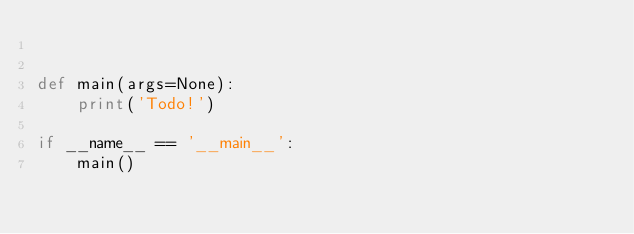Convert code to text. <code><loc_0><loc_0><loc_500><loc_500><_Python_>

def main(args=None):
    print('Todo!')

if __name__ == '__main__':
    main()
</code> 